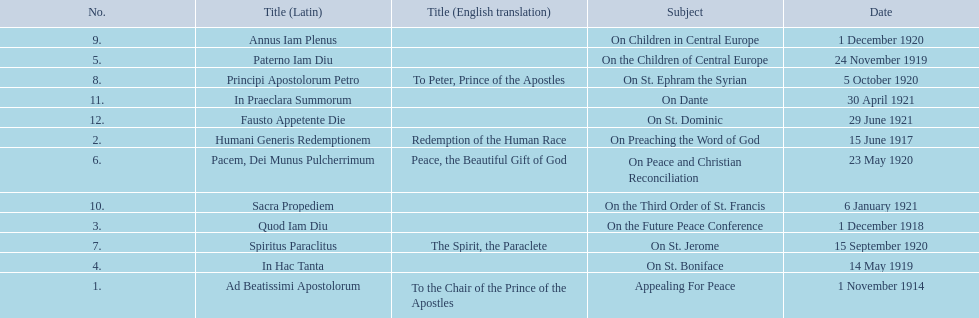What are all the subjects? Appealing For Peace, On Preaching the Word of God, On the Future Peace Conference, On St. Boniface, On the Children of Central Europe, On Peace and Christian Reconciliation, On St. Jerome, On St. Ephram the Syrian, On Children in Central Europe, On the Third Order of St. Francis, On Dante, On St. Dominic. Which occurred in 1920? On Peace and Christian Reconciliation, On St. Jerome, On St. Ephram the Syrian, On Children in Central Europe. Which occurred in may of that year? On Peace and Christian Reconciliation. 